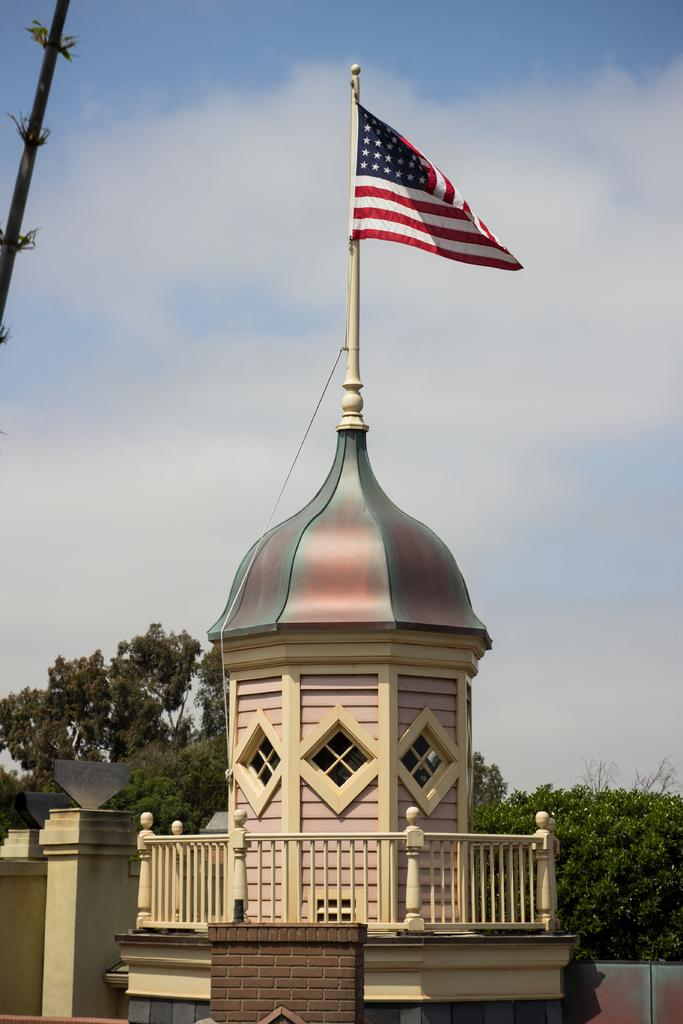What is the main subject in the center of the image? There is a flag in the center of the image. How is the flag connected to the surrounding environment? The flag is attached to a building. What can be seen in the background of the image? There are trees and the sky visible in the background of the image. What is the condition of the sky in the image? The sky has clouds in it. What type of books is the mom reading to the carpenter in the image? There is no mom, carpenter, or books present in the image; it only features a flag attached to a building with trees and clouds in the background. 